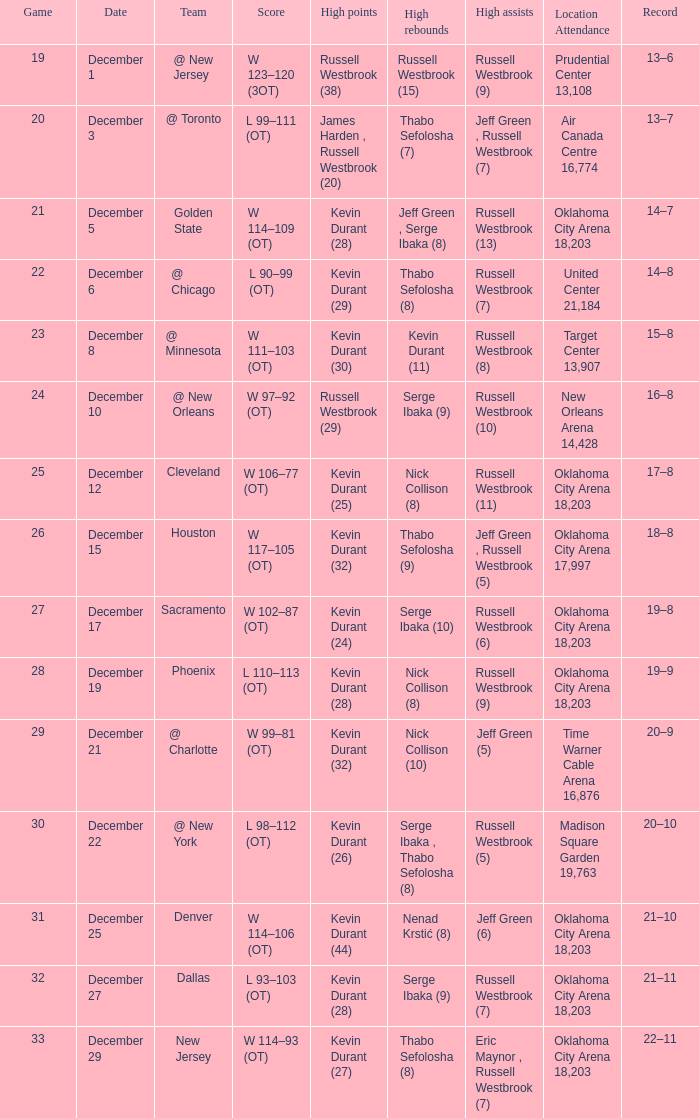Who had the high rebounds record on December 12? Nick Collison (8). Help me parse the entirety of this table. {'header': ['Game', 'Date', 'Team', 'Score', 'High points', 'High rebounds', 'High assists', 'Location Attendance', 'Record'], 'rows': [['19', 'December 1', '@ New Jersey', 'W 123–120 (3OT)', 'Russell Westbrook (38)', 'Russell Westbrook (15)', 'Russell Westbrook (9)', 'Prudential Center 13,108', '13–6'], ['20', 'December 3', '@ Toronto', 'L 99–111 (OT)', 'James Harden , Russell Westbrook (20)', 'Thabo Sefolosha (7)', 'Jeff Green , Russell Westbrook (7)', 'Air Canada Centre 16,774', '13–7'], ['21', 'December 5', 'Golden State', 'W 114–109 (OT)', 'Kevin Durant (28)', 'Jeff Green , Serge Ibaka (8)', 'Russell Westbrook (13)', 'Oklahoma City Arena 18,203', '14–7'], ['22', 'December 6', '@ Chicago', 'L 90–99 (OT)', 'Kevin Durant (29)', 'Thabo Sefolosha (8)', 'Russell Westbrook (7)', 'United Center 21,184', '14–8'], ['23', 'December 8', '@ Minnesota', 'W 111–103 (OT)', 'Kevin Durant (30)', 'Kevin Durant (11)', 'Russell Westbrook (8)', 'Target Center 13,907', '15–8'], ['24', 'December 10', '@ New Orleans', 'W 97–92 (OT)', 'Russell Westbrook (29)', 'Serge Ibaka (9)', 'Russell Westbrook (10)', 'New Orleans Arena 14,428', '16–8'], ['25', 'December 12', 'Cleveland', 'W 106–77 (OT)', 'Kevin Durant (25)', 'Nick Collison (8)', 'Russell Westbrook (11)', 'Oklahoma City Arena 18,203', '17–8'], ['26', 'December 15', 'Houston', 'W 117–105 (OT)', 'Kevin Durant (32)', 'Thabo Sefolosha (9)', 'Jeff Green , Russell Westbrook (5)', 'Oklahoma City Arena 17,997', '18–8'], ['27', 'December 17', 'Sacramento', 'W 102–87 (OT)', 'Kevin Durant (24)', 'Serge Ibaka (10)', 'Russell Westbrook (6)', 'Oklahoma City Arena 18,203', '19–8'], ['28', 'December 19', 'Phoenix', 'L 110–113 (OT)', 'Kevin Durant (28)', 'Nick Collison (8)', 'Russell Westbrook (9)', 'Oklahoma City Arena 18,203', '19–9'], ['29', 'December 21', '@ Charlotte', 'W 99–81 (OT)', 'Kevin Durant (32)', 'Nick Collison (10)', 'Jeff Green (5)', 'Time Warner Cable Arena 16,876', '20–9'], ['30', 'December 22', '@ New York', 'L 98–112 (OT)', 'Kevin Durant (26)', 'Serge Ibaka , Thabo Sefolosha (8)', 'Russell Westbrook (5)', 'Madison Square Garden 19,763', '20–10'], ['31', 'December 25', 'Denver', 'W 114–106 (OT)', 'Kevin Durant (44)', 'Nenad Krstić (8)', 'Jeff Green (6)', 'Oklahoma City Arena 18,203', '21–10'], ['32', 'December 27', 'Dallas', 'L 93–103 (OT)', 'Kevin Durant (28)', 'Serge Ibaka (9)', 'Russell Westbrook (7)', 'Oklahoma City Arena 18,203', '21–11'], ['33', 'December 29', 'New Jersey', 'W 114–93 (OT)', 'Kevin Durant (27)', 'Thabo Sefolosha (8)', 'Eric Maynor , Russell Westbrook (7)', 'Oklahoma City Arena 18,203', '22–11']]} 